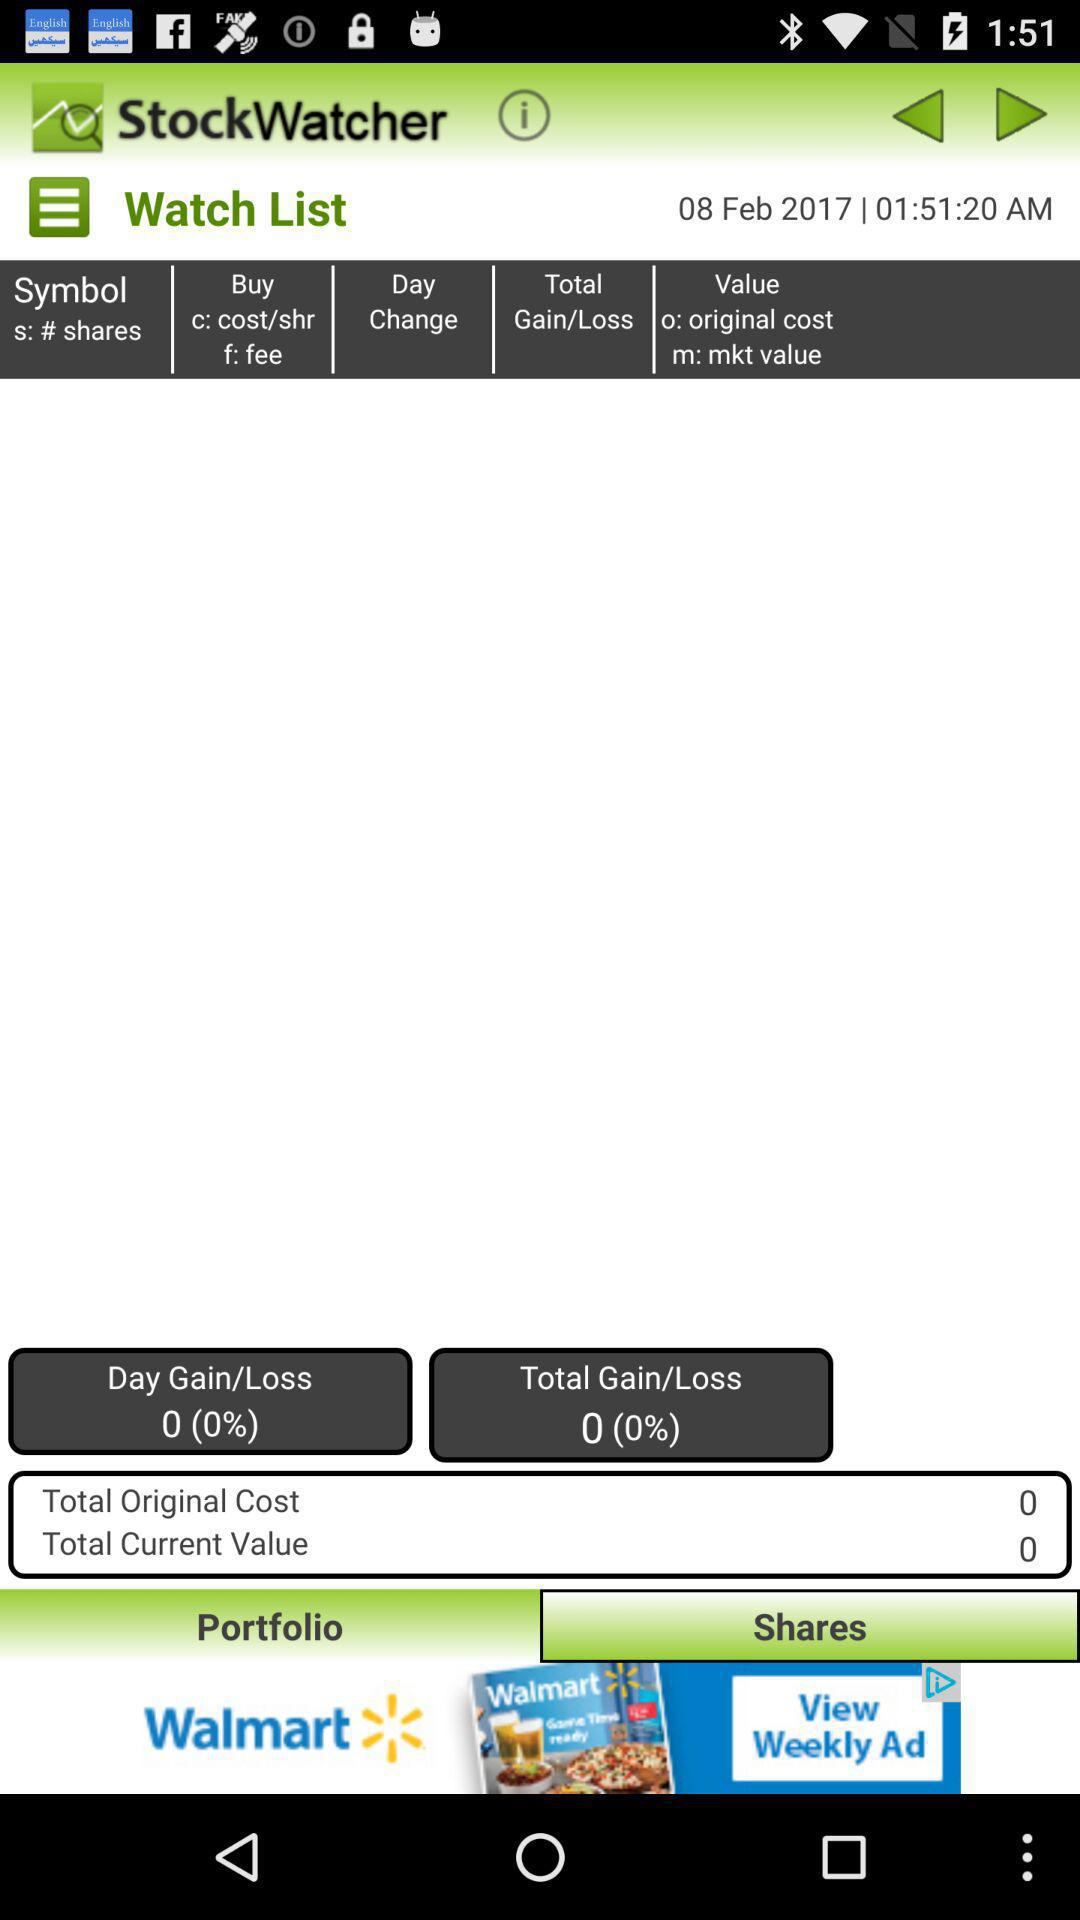What is the mentioned time? The mentioned time is 01:51:20 AM. 